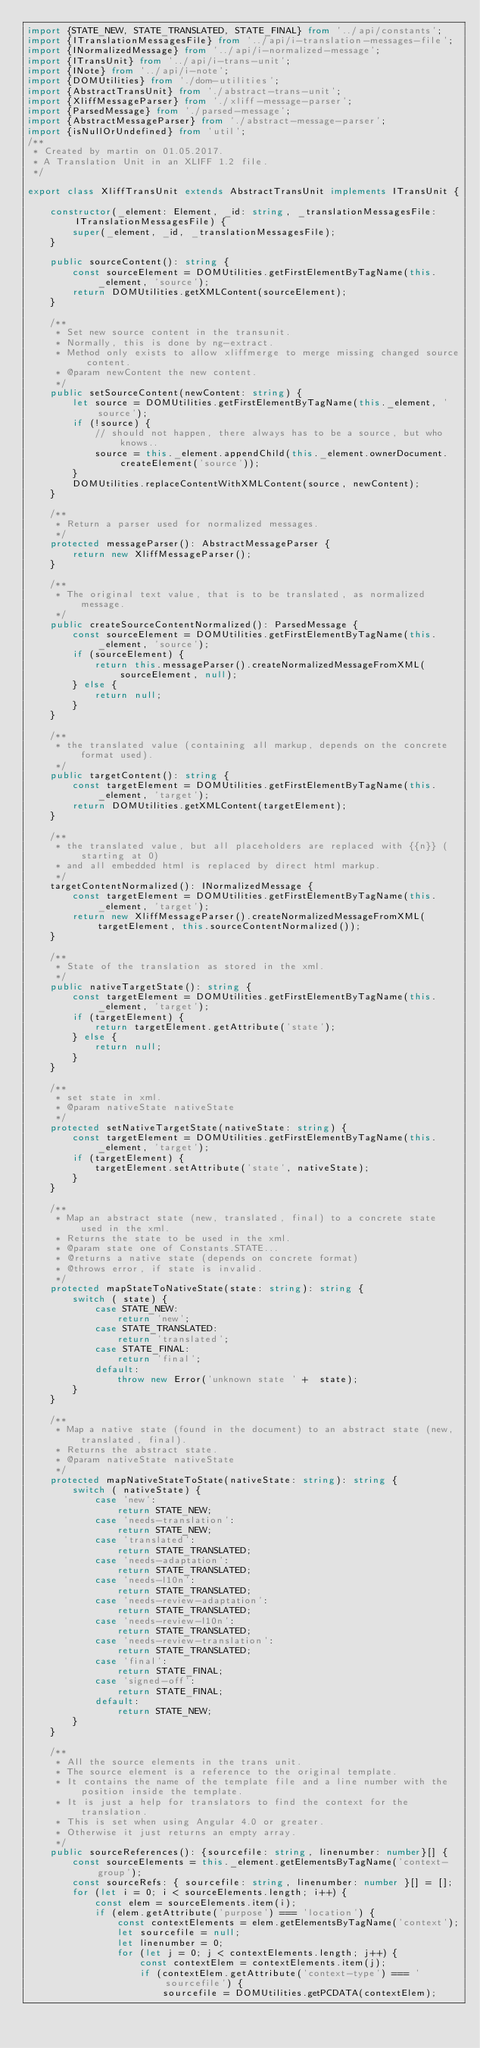Convert code to text. <code><loc_0><loc_0><loc_500><loc_500><_TypeScript_>import {STATE_NEW, STATE_TRANSLATED, STATE_FINAL} from '../api/constants';
import {ITranslationMessagesFile} from '../api/i-translation-messages-file';
import {INormalizedMessage} from '../api/i-normalized-message';
import {ITransUnit} from '../api/i-trans-unit';
import {INote} from '../api/i-note';
import {DOMUtilities} from './dom-utilities';
import {AbstractTransUnit} from './abstract-trans-unit';
import {XliffMessageParser} from './xliff-message-parser';
import {ParsedMessage} from './parsed-message';
import {AbstractMessageParser} from './abstract-message-parser';
import {isNullOrUndefined} from 'util';
/**
 * Created by martin on 01.05.2017.
 * A Translation Unit in an XLIFF 1.2 file.
 */

export class XliffTransUnit extends AbstractTransUnit implements ITransUnit {

    constructor(_element: Element, _id: string, _translationMessagesFile: ITranslationMessagesFile) {
        super(_element, _id, _translationMessagesFile);
    }

    public sourceContent(): string {
        const sourceElement = DOMUtilities.getFirstElementByTagName(this._element, 'source');
        return DOMUtilities.getXMLContent(sourceElement);
    }

    /**
     * Set new source content in the transunit.
     * Normally, this is done by ng-extract.
     * Method only exists to allow xliffmerge to merge missing changed source content.
     * @param newContent the new content.
     */
    public setSourceContent(newContent: string) {
        let source = DOMUtilities.getFirstElementByTagName(this._element, 'source');
        if (!source) {
            // should not happen, there always has to be a source, but who knows..
            source = this._element.appendChild(this._element.ownerDocument.createElement('source'));
        }
        DOMUtilities.replaceContentWithXMLContent(source, newContent);
    }

    /**
     * Return a parser used for normalized messages.
     */
    protected messageParser(): AbstractMessageParser {
        return new XliffMessageParser();
    }

    /**
     * The original text value, that is to be translated, as normalized message.
     */
    public createSourceContentNormalized(): ParsedMessage {
        const sourceElement = DOMUtilities.getFirstElementByTagName(this._element, 'source');
        if (sourceElement) {
            return this.messageParser().createNormalizedMessageFromXML(sourceElement, null);
        } else {
            return null;
        }
    }

    /**
     * the translated value (containing all markup, depends on the concrete format used).
     */
    public targetContent(): string {
        const targetElement = DOMUtilities.getFirstElementByTagName(this._element, 'target');
        return DOMUtilities.getXMLContent(targetElement);
    }

    /**
     * the translated value, but all placeholders are replaced with {{n}} (starting at 0)
     * and all embedded html is replaced by direct html markup.
     */
    targetContentNormalized(): INormalizedMessage {
        const targetElement = DOMUtilities.getFirstElementByTagName(this._element, 'target');
        return new XliffMessageParser().createNormalizedMessageFromXML(targetElement, this.sourceContentNormalized());
    }

    /**
     * State of the translation as stored in the xml.
     */
    public nativeTargetState(): string {
        const targetElement = DOMUtilities.getFirstElementByTagName(this._element, 'target');
        if (targetElement) {
            return targetElement.getAttribute('state');
        } else {
            return null;
        }
    }

    /**
     * set state in xml.
     * @param nativeState nativeState
     */
    protected setNativeTargetState(nativeState: string) {
        const targetElement = DOMUtilities.getFirstElementByTagName(this._element, 'target');
        if (targetElement) {
            targetElement.setAttribute('state', nativeState);
        }
    }

    /**
     * Map an abstract state (new, translated, final) to a concrete state used in the xml.
     * Returns the state to be used in the xml.
     * @param state one of Constants.STATE...
     * @returns a native state (depends on concrete format)
     * @throws error, if state is invalid.
     */
    protected mapStateToNativeState(state: string): string {
        switch ( state) {
            case STATE_NEW:
                return 'new';
            case STATE_TRANSLATED:
                return 'translated';
            case STATE_FINAL:
                return 'final';
            default:
                throw new Error('unknown state ' +  state);
        }
    }

    /**
     * Map a native state (found in the document) to an abstract state (new, translated, final).
     * Returns the abstract state.
     * @param nativeState nativeState
     */
    protected mapNativeStateToState(nativeState: string): string {
        switch ( nativeState) {
            case 'new':
                return STATE_NEW;
            case 'needs-translation':
                return STATE_NEW;
            case 'translated':
                return STATE_TRANSLATED;
            case 'needs-adaptation':
                return STATE_TRANSLATED;
            case 'needs-l10n':
                return STATE_TRANSLATED;
            case 'needs-review-adaptation':
                return STATE_TRANSLATED;
            case 'needs-review-l10n':
                return STATE_TRANSLATED;
            case 'needs-review-translation':
                return STATE_TRANSLATED;
            case 'final':
                return STATE_FINAL;
            case 'signed-off':
                return STATE_FINAL;
            default:
                return STATE_NEW;
        }
    }

    /**
     * All the source elements in the trans unit.
     * The source element is a reference to the original template.
     * It contains the name of the template file and a line number with the position inside the template.
     * It is just a help for translators to find the context for the translation.
     * This is set when using Angular 4.0 or greater.
     * Otherwise it just returns an empty array.
     */
    public sourceReferences(): {sourcefile: string, linenumber: number}[] {
        const sourceElements = this._element.getElementsByTagName('context-group');
        const sourceRefs: { sourcefile: string, linenumber: number }[] = [];
        for (let i = 0; i < sourceElements.length; i++) {
            const elem = sourceElements.item(i);
            if (elem.getAttribute('purpose') === 'location') {
                const contextElements = elem.getElementsByTagName('context');
                let sourcefile = null;
                let linenumber = 0;
                for (let j = 0; j < contextElements.length; j++) {
                    const contextElem = contextElements.item(j);
                    if (contextElem.getAttribute('context-type') === 'sourcefile') {
                        sourcefile = DOMUtilities.getPCDATA(contextElem);</code> 